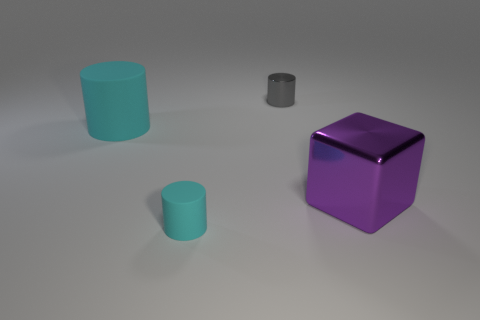Add 1 large red shiny things. How many objects exist? 5 Subtract all cubes. How many objects are left? 3 Add 4 metallic cylinders. How many metallic cylinders are left? 5 Add 3 big purple objects. How many big purple objects exist? 4 Subtract 0 red cubes. How many objects are left? 4 Subtract all big brown shiny balls. Subtract all cubes. How many objects are left? 3 